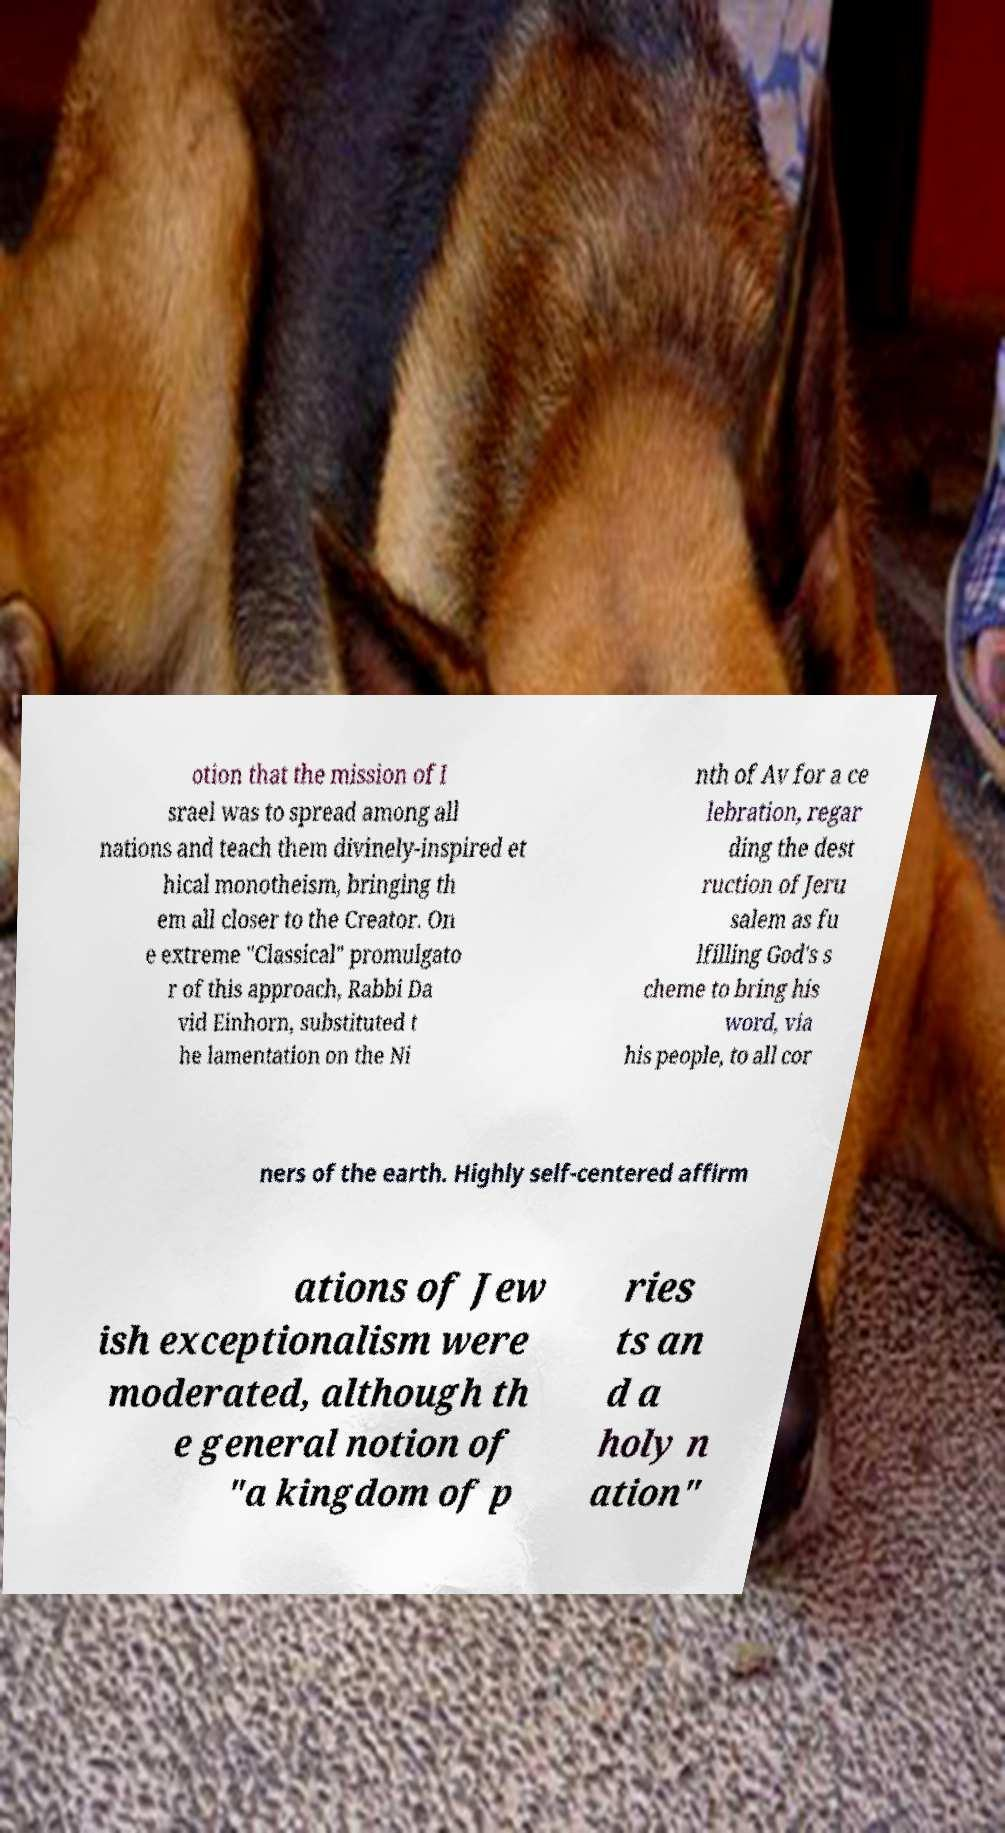There's text embedded in this image that I need extracted. Can you transcribe it verbatim? otion that the mission of I srael was to spread among all nations and teach them divinely-inspired et hical monotheism, bringing th em all closer to the Creator. On e extreme "Classical" promulgato r of this approach, Rabbi Da vid Einhorn, substituted t he lamentation on the Ni nth of Av for a ce lebration, regar ding the dest ruction of Jeru salem as fu lfilling God's s cheme to bring his word, via his people, to all cor ners of the earth. Highly self-centered affirm ations of Jew ish exceptionalism were moderated, although th e general notion of "a kingdom of p ries ts an d a holy n ation" 